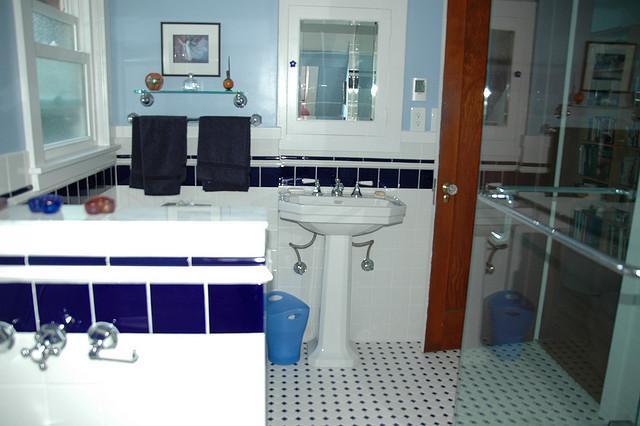How many sinks are in the bathroom?
Give a very brief answer. 1. How many people are to the left of the person standing?
Give a very brief answer. 0. 